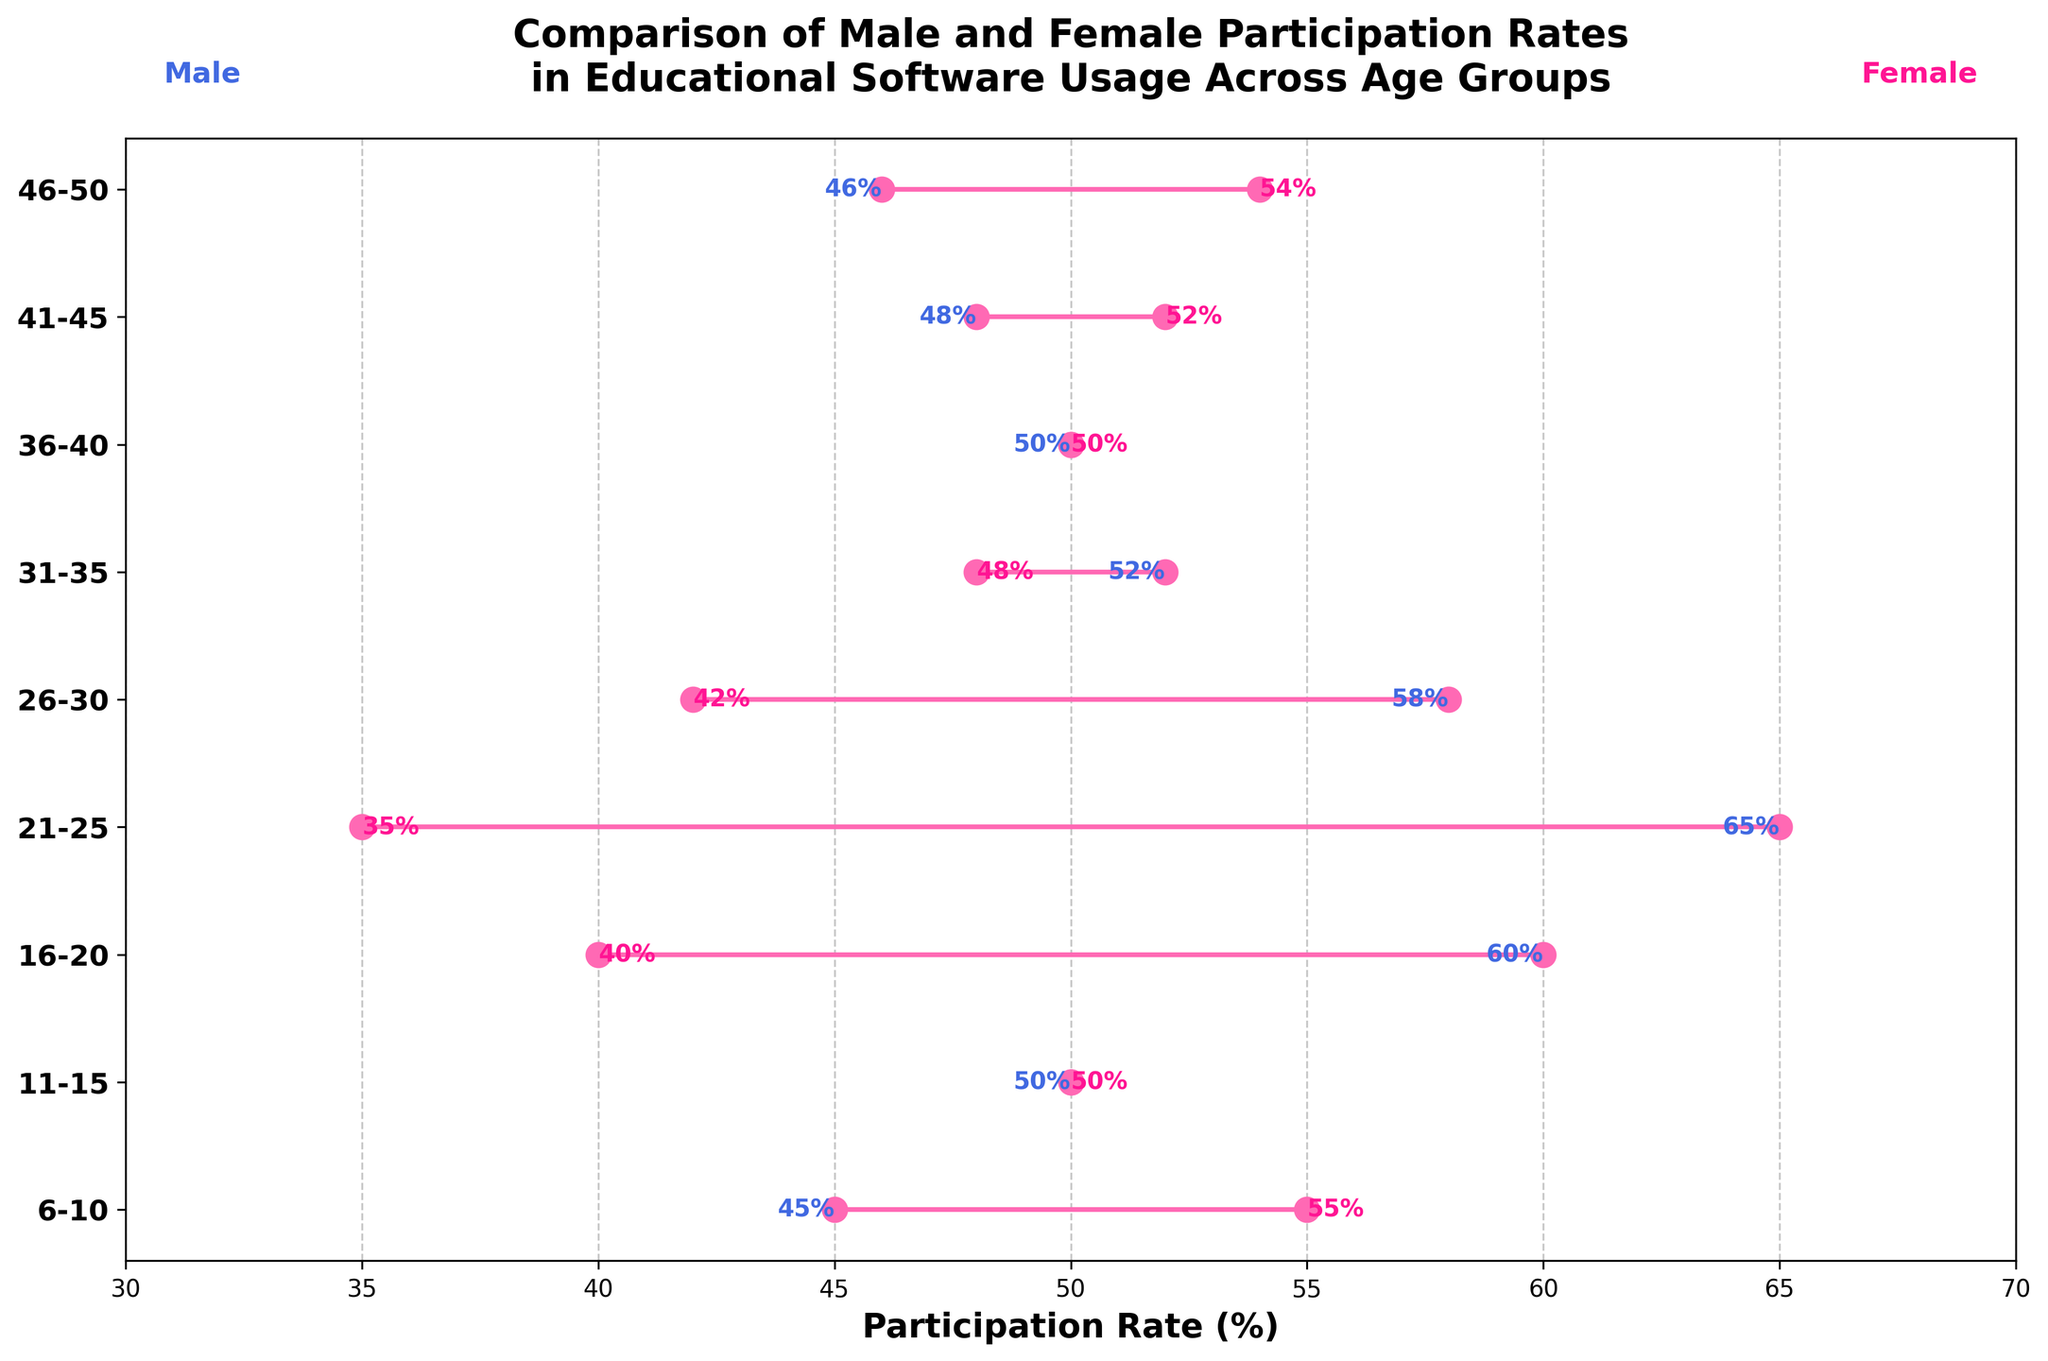Which age group shows the highest male participation rate? The peak male participation rate, depicted by the farthest right blue marker, is at the 21-25 age group showing 65%.
Answer: 21-25 What is the title of the plot? The title of the plot appears at the very top and reads: 'Comparison of Male and Female Participation Rates in Educational Software Usage Across Age Groups'.
Answer: 'Comparison of Male and Female Participation Rates in Educational Software Usage Across Age Groups' What is the difference in participation rates between males and females in the 36-40 age group? The rates for both males and females in the 36-40 age group are the same: 50% each, resulting in a difference of 0%.
Answer: 0% Identify the age group with the smallest gender gap in participation rates. The gender gaps can be identified by the closeness between the blue and pink markers. Age groups 11-15 and 36-40 both have rates of 50%, meaning the smallest gap is 0%.
Answer: 11-15 and 36-40 Between which age groups does female participation consistently outpace male participation? By examining the plot where pink markers are notably to the right of blue, the age groups 6-10, 41-45, and 46-50 show female participation rates being higher than male.
Answer: 6-10, 41-45, and 46-50 What are the overall trends for male and female participation rates across age groups? Examining the plot, male participation generally increases, peaks at 21-25, and declines slightly, while female starts high at 6-10, drops sharply to 40% at 16-20, and generally increases again up to 46-50.
Answer: Males increase then slightly decrease; Females decrease then increase How does the male and female participation rate compare in the 26-30 age group? Blue and pink markers show rates of 58% for males and 42% for females in the 26-30 age group, confirming males outpace females by approximately 16%.
Answer: Males are 16% higher Which age group shows the closest participation rates between genders? The plot displays tied rates (markers overlap) at age groups 11-15 and 36-40, both with 50% for male and female.
Answer: 11-15 and 36-40 What is the average male participation rate across all age groups? Adding up male rates: 45 + 50 + 60 + 65 + 58 + 52 + 50 + 48 + 46 = 474 and then dividing by 9 groups yields an average of approximately 52.67%.
Answer: 52.67% What is the median female participation rate? Arranging rates: [35, 40, 42, 48, 50, 50, 52, 54, 55], the median rate (central value) for females is 50%.
Answer: 50% 